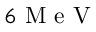Convert formula to latex. <formula><loc_0><loc_0><loc_500><loc_500>6 M e V</formula> 